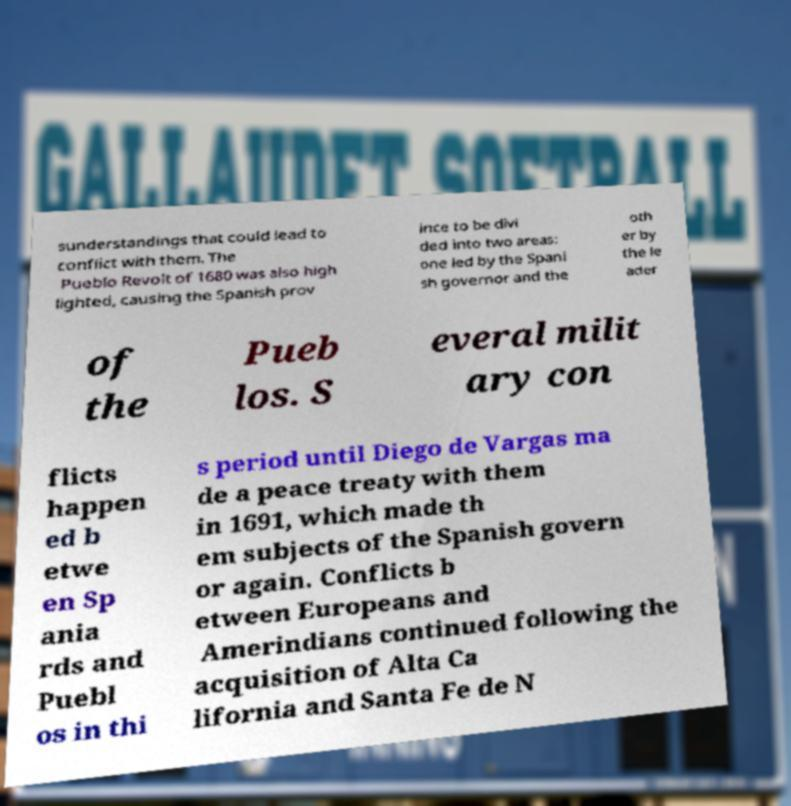Could you extract and type out the text from this image? sunderstandings that could lead to conflict with them. The Pueblo Revolt of 1680 was also high lighted, causing the Spanish prov ince to be divi ded into two areas: one led by the Spani sh governor and the oth er by the le ader of the Pueb los. S everal milit ary con flicts happen ed b etwe en Sp ania rds and Puebl os in thi s period until Diego de Vargas ma de a peace treaty with them in 1691, which made th em subjects of the Spanish govern or again. Conflicts b etween Europeans and Amerindians continued following the acquisition of Alta Ca lifornia and Santa Fe de N 